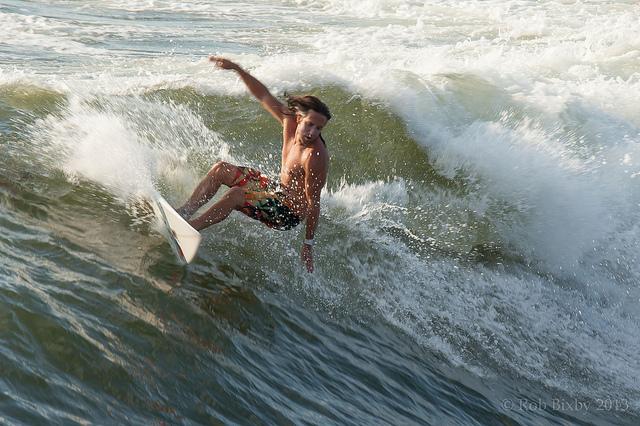How long can he last on the surf board?
Short answer required. 30 seconds. Is the wave big?
Give a very brief answer. Yes. Is he wearing a shirt?
Concise answer only. No. What color is the band on the surfers wrist?
Concise answer only. White. What color is the surfboard?
Quick response, please. White. 